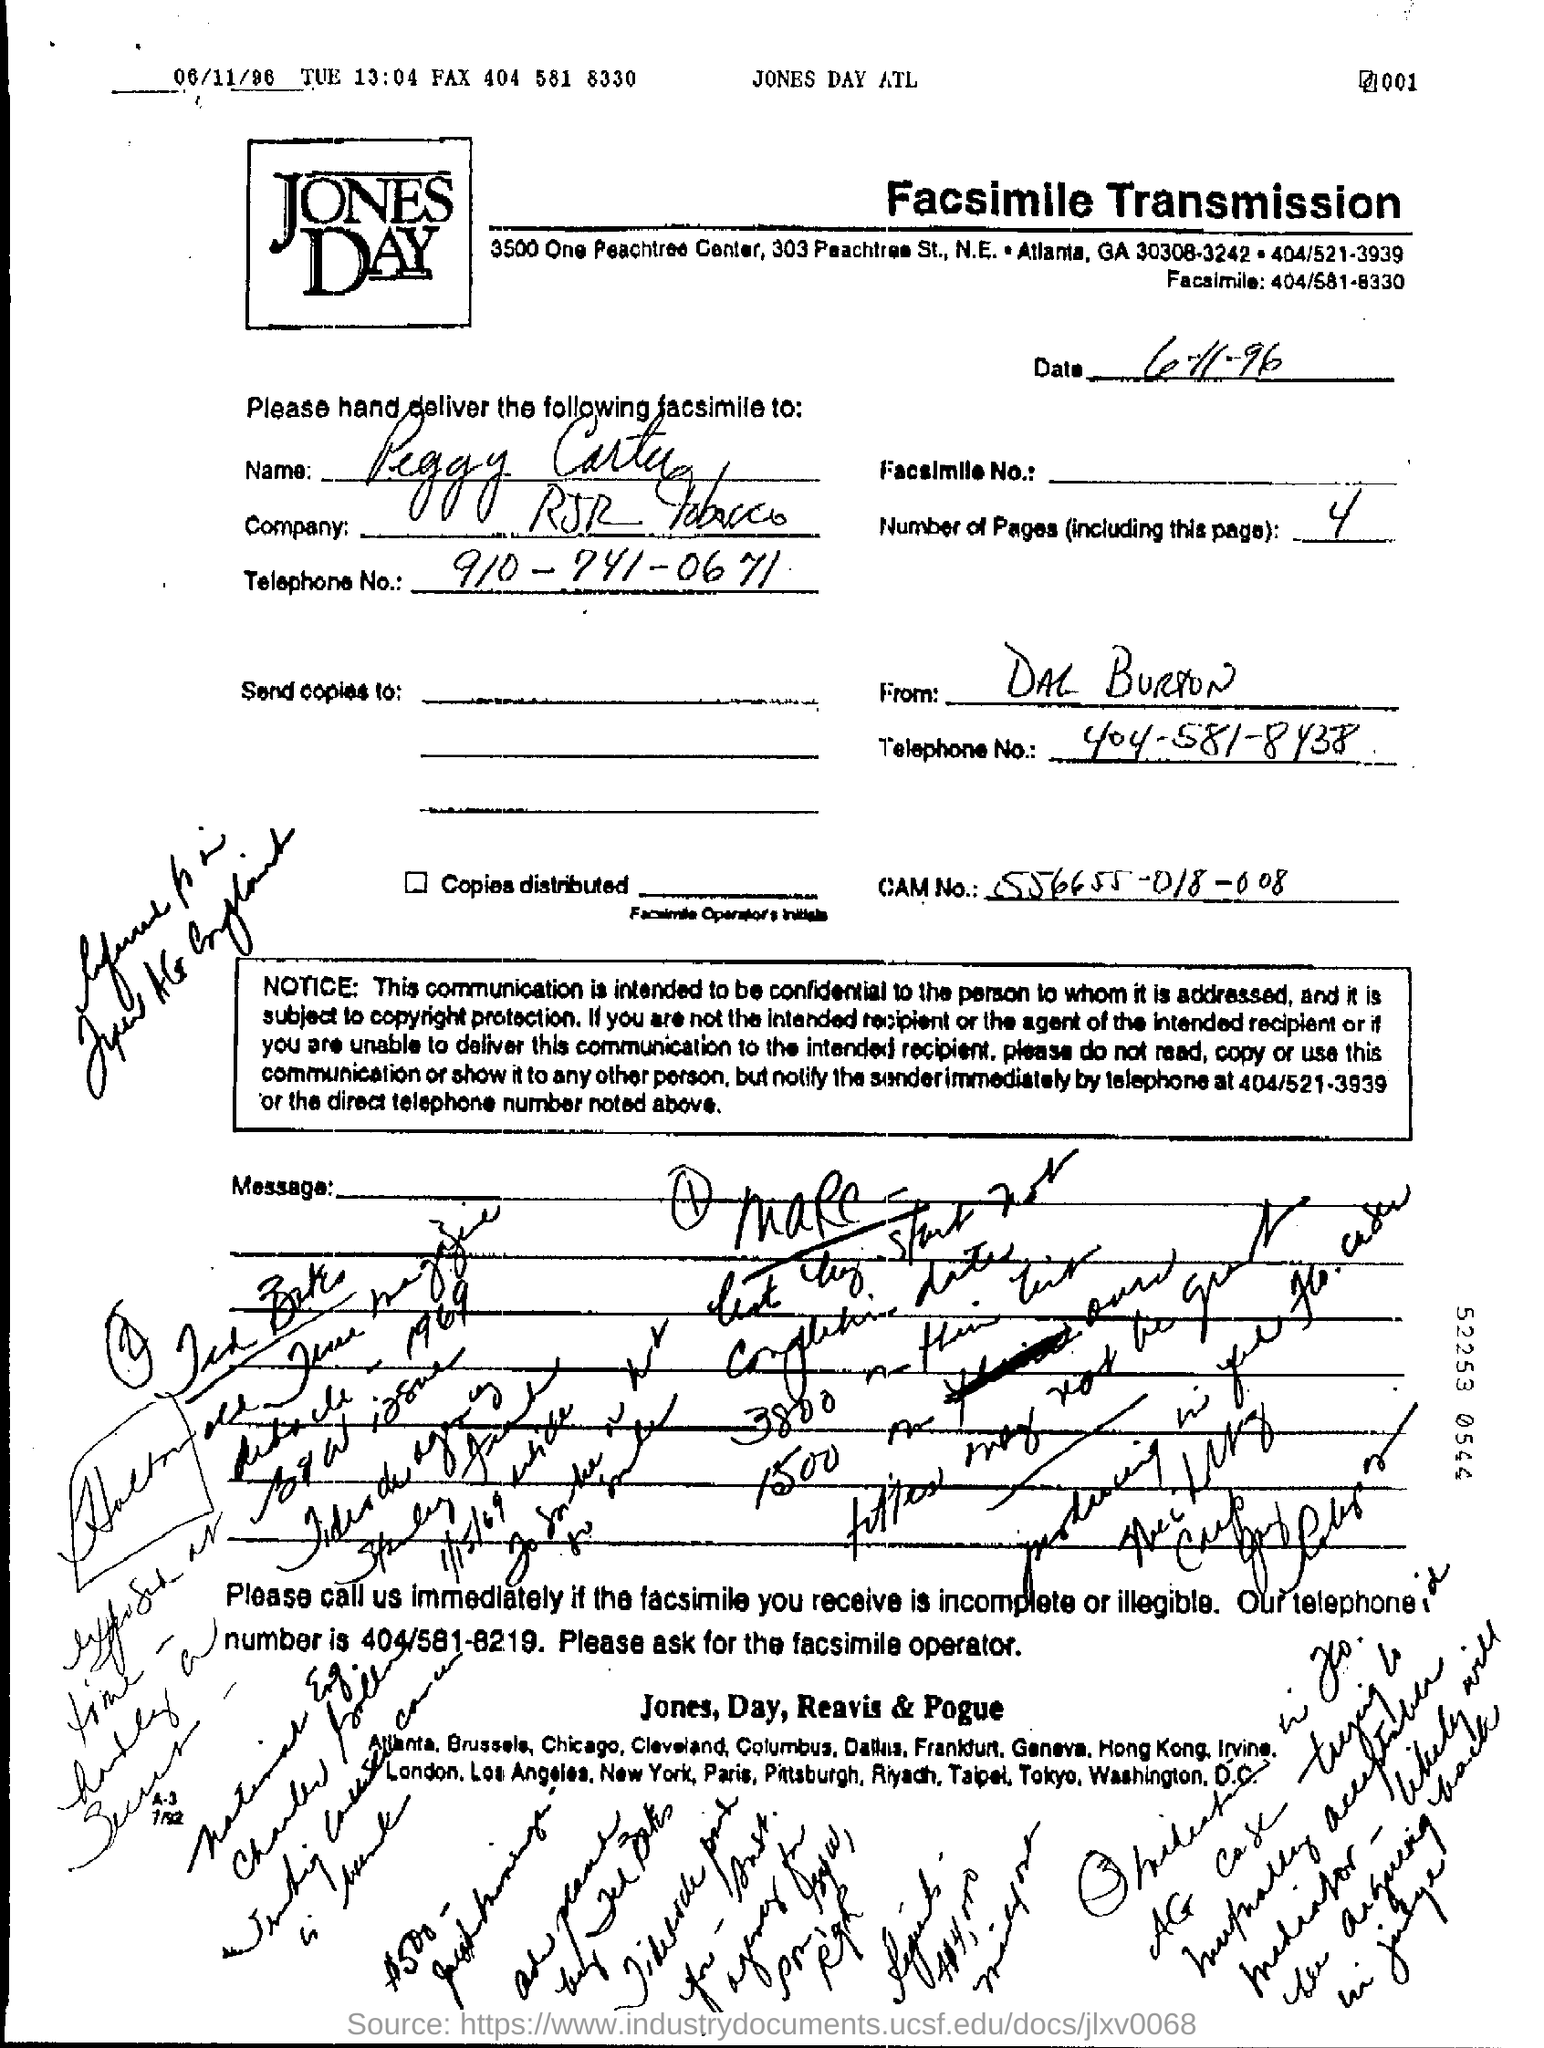Highlight a few significant elements in this photo. The date mentioned in the page is 6th November 1996. There are a total of 4 pages, including the current page. 